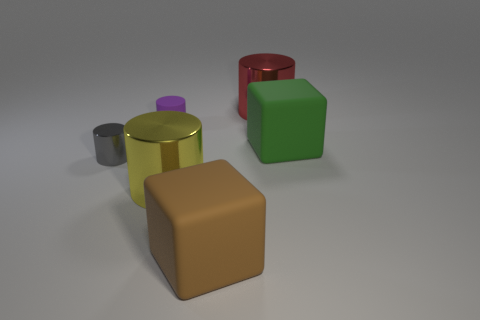Add 1 tiny gray balls. How many objects exist? 7 Subtract all blocks. How many objects are left? 4 Add 2 tiny cylinders. How many tiny cylinders exist? 4 Subtract 0 green balls. How many objects are left? 6 Subtract all tiny purple metal blocks. Subtract all matte things. How many objects are left? 3 Add 5 tiny cylinders. How many tiny cylinders are left? 7 